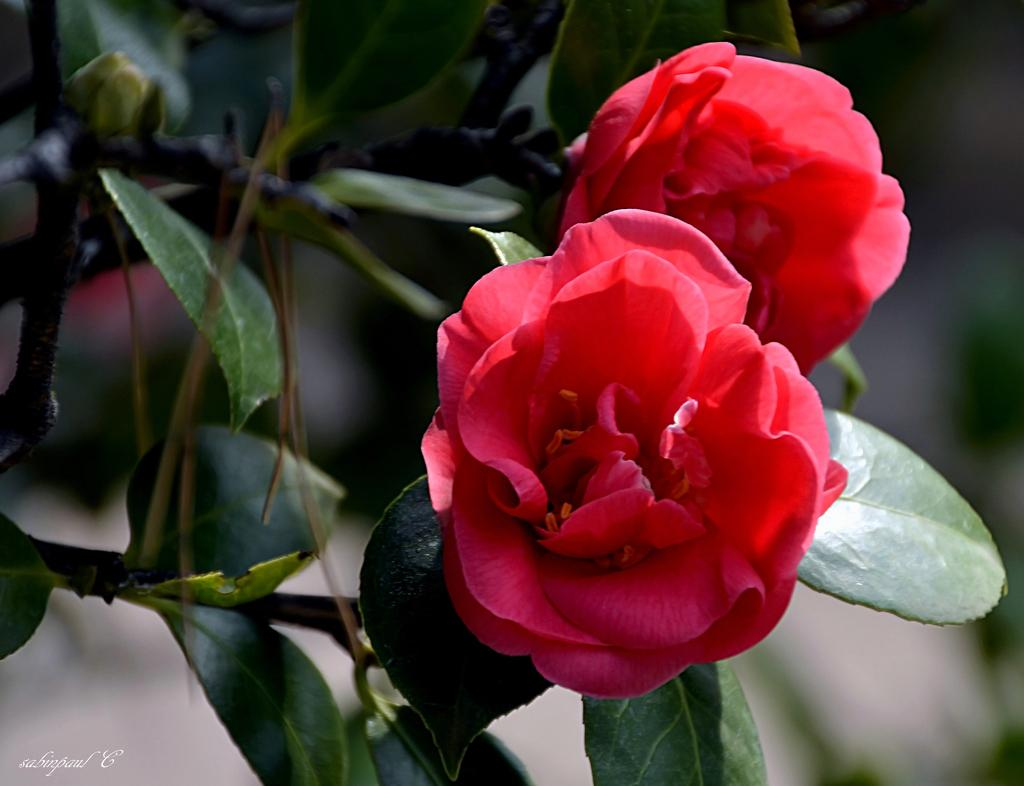How many flowers can be seen in the image? There are two red flowers in the image. What is the color of the flowers? The flowers are red. What is the flowers attached to? The flowers are attached to a plant. What colors are present on the plant? The plant has a green and brown color. What can be observed about the background of the image? The background of the image is blurry. What type of health advice can be heard from the flowers in the image? There is no voice or health advice present in the image; it features two red flowers attached to a plant. 